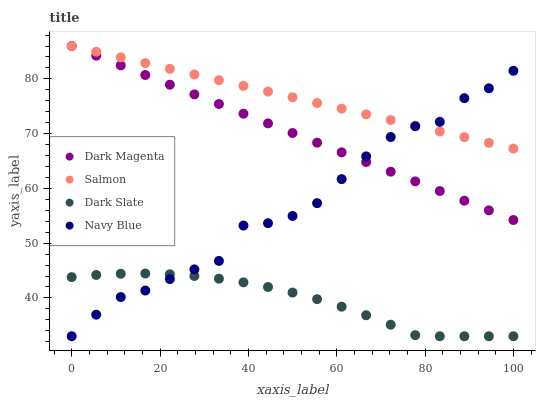Does Dark Slate have the minimum area under the curve?
Answer yes or no. Yes. Does Salmon have the maximum area under the curve?
Answer yes or no. Yes. Does Dark Magenta have the minimum area under the curve?
Answer yes or no. No. Does Dark Magenta have the maximum area under the curve?
Answer yes or no. No. Is Salmon the smoothest?
Answer yes or no. Yes. Is Navy Blue the roughest?
Answer yes or no. Yes. Is Dark Magenta the smoothest?
Answer yes or no. No. Is Dark Magenta the roughest?
Answer yes or no. No. Does Dark Slate have the lowest value?
Answer yes or no. Yes. Does Dark Magenta have the lowest value?
Answer yes or no. No. Does Dark Magenta have the highest value?
Answer yes or no. Yes. Does Navy Blue have the highest value?
Answer yes or no. No. Is Dark Slate less than Dark Magenta?
Answer yes or no. Yes. Is Salmon greater than Dark Slate?
Answer yes or no. Yes. Does Salmon intersect Navy Blue?
Answer yes or no. Yes. Is Salmon less than Navy Blue?
Answer yes or no. No. Is Salmon greater than Navy Blue?
Answer yes or no. No. Does Dark Slate intersect Dark Magenta?
Answer yes or no. No. 